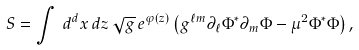<formula> <loc_0><loc_0><loc_500><loc_500>S = \int \, d ^ { d } x \, d z \, \sqrt { g } \, e ^ { \varphi ( z ) } \left ( g ^ { \ell m } \partial _ { \ell } \Phi ^ { * } \partial _ { m } \Phi - \mu ^ { 2 } \Phi ^ { * } \Phi \right ) ,</formula> 